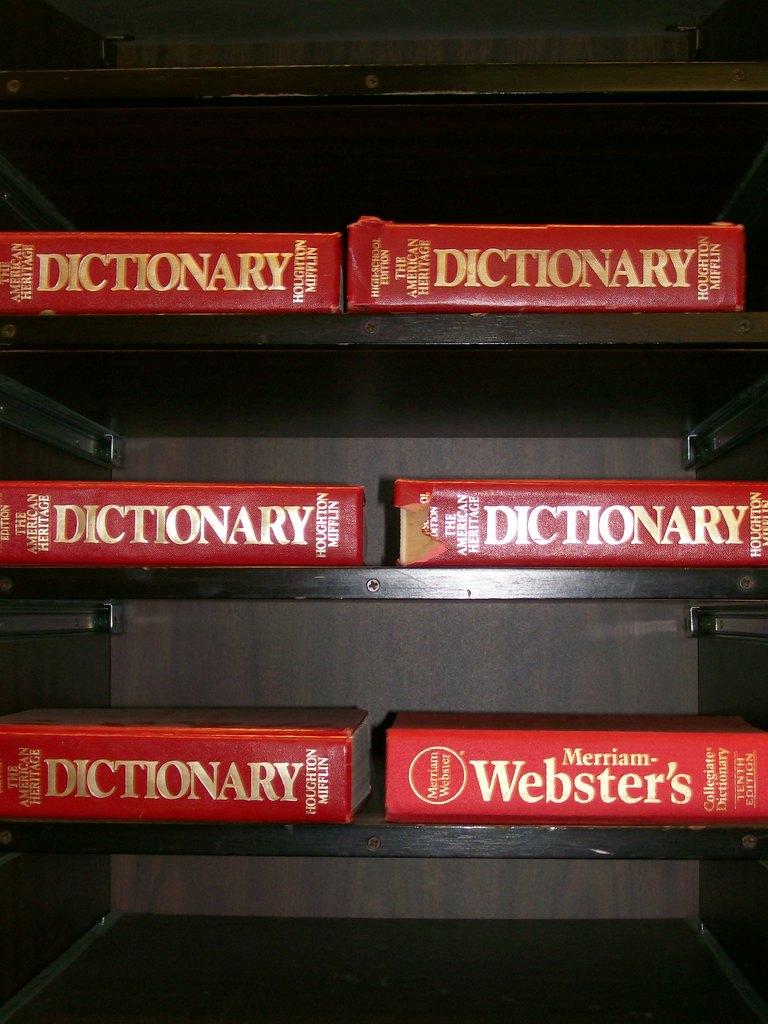Are all the dictionaries the same?
Offer a very short reply. No. Who is the publisher of the bottom right book?
Your answer should be very brief. Merriam webster. 